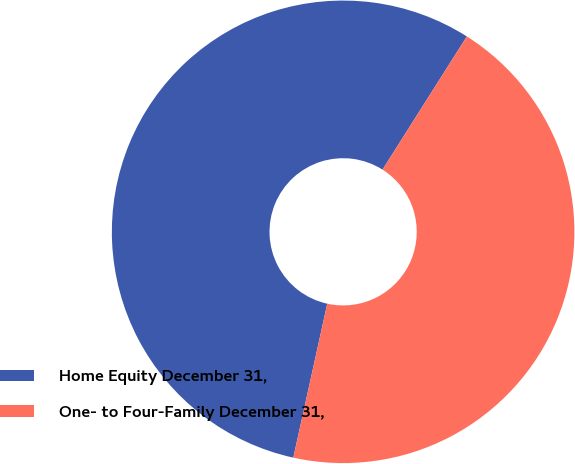Convert chart to OTSL. <chart><loc_0><loc_0><loc_500><loc_500><pie_chart><fcel>Home Equity December 31,<fcel>One- to Four-Family December 31,<nl><fcel>55.53%<fcel>44.47%<nl></chart> 